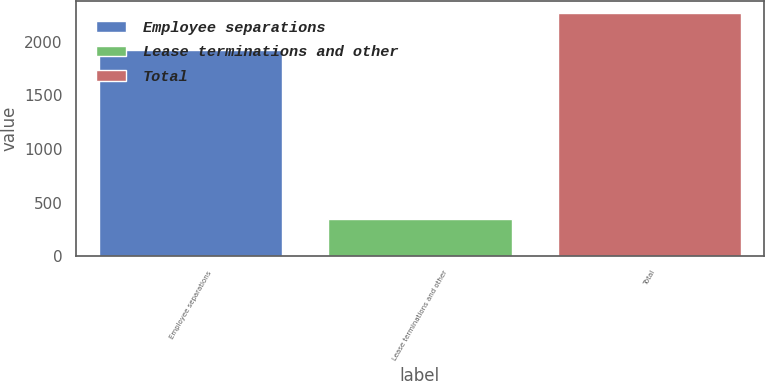Convert chart to OTSL. <chart><loc_0><loc_0><loc_500><loc_500><bar_chart><fcel>Employee separations<fcel>Lease terminations and other<fcel>Total<nl><fcel>1919<fcel>347<fcel>2266<nl></chart> 